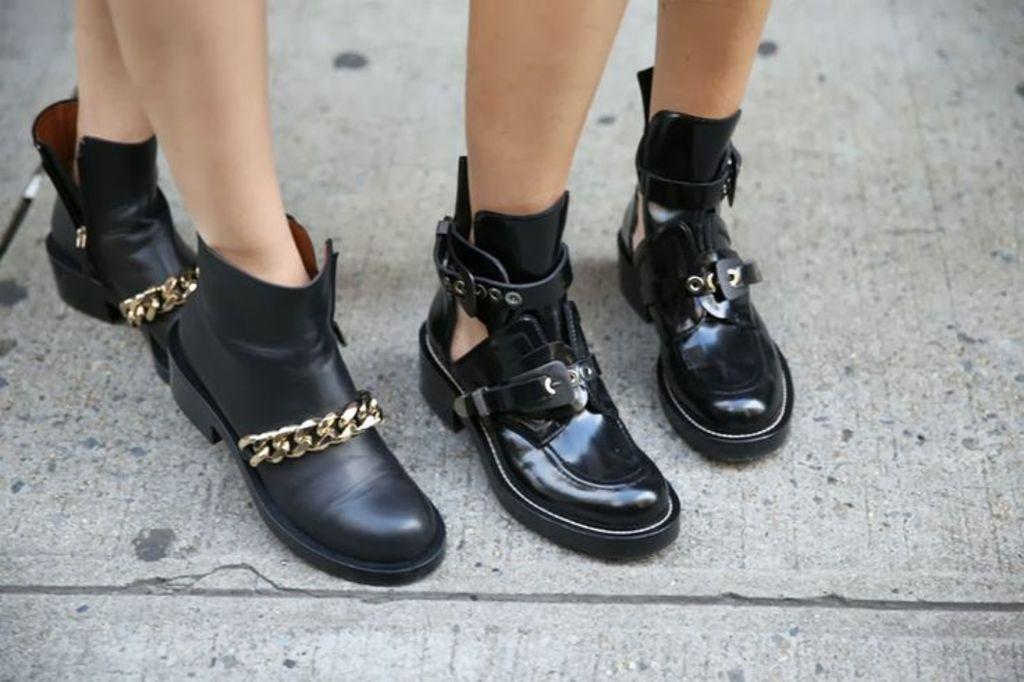How many people are present in the image based on the visible legs? There are two people in the image based on the visible legs. What type of footwear are the people wearing? The people are wearing shoes. What color is the furniture in the image? There is no furniture present in the image; it only shows the legs of two people wearing shoes. 